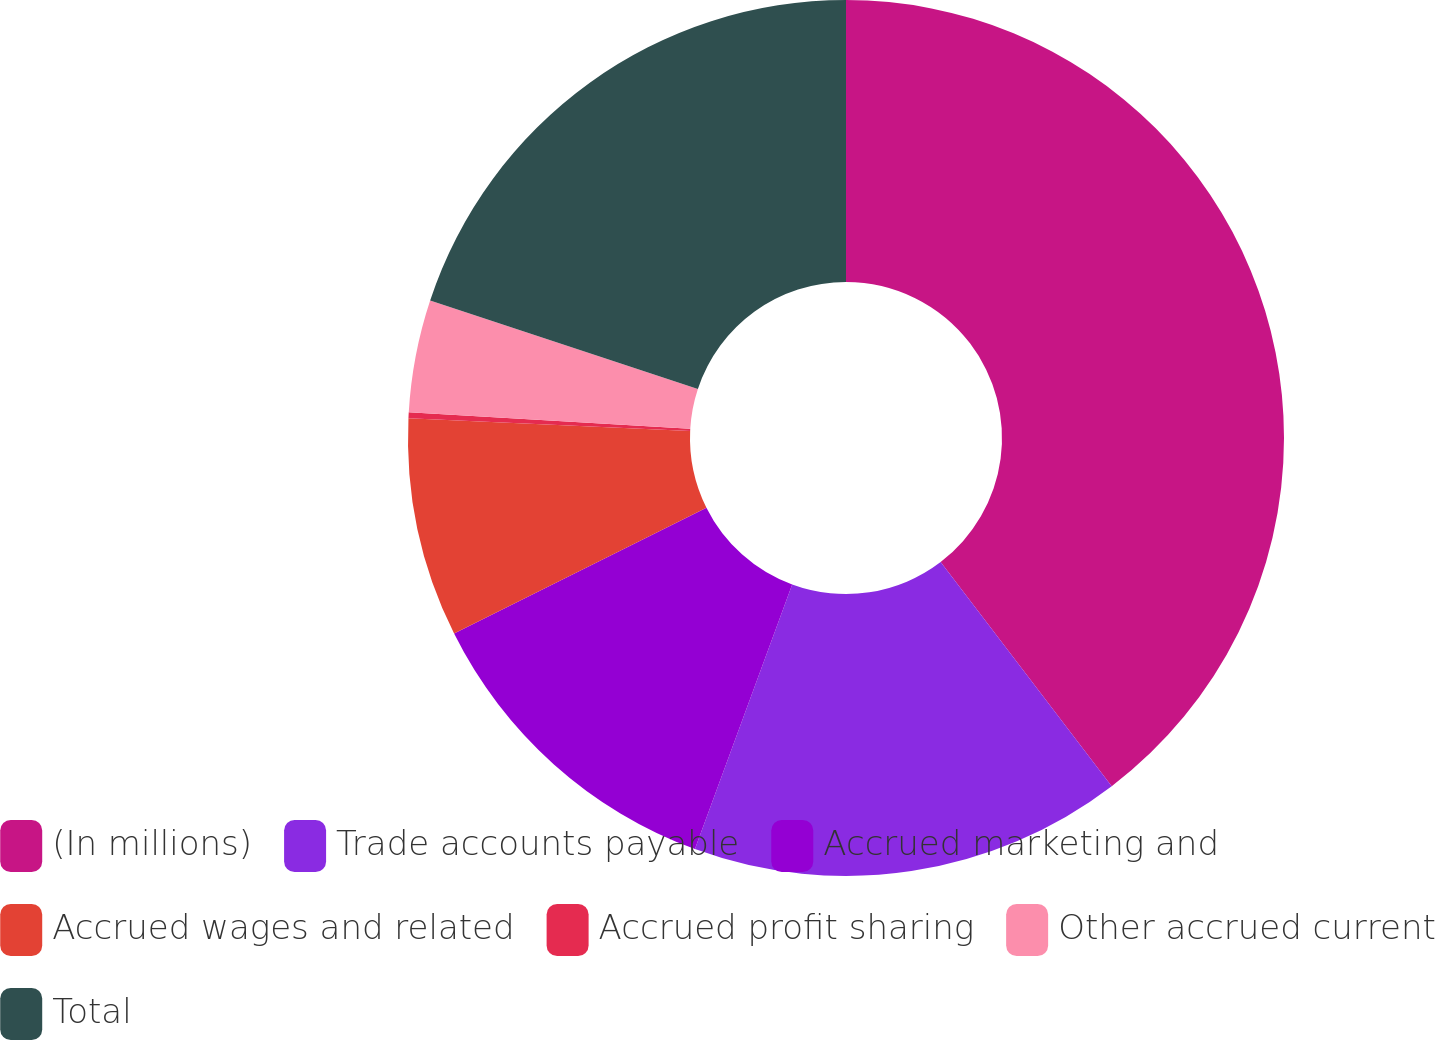Convert chart. <chart><loc_0><loc_0><loc_500><loc_500><pie_chart><fcel>(In millions)<fcel>Trade accounts payable<fcel>Accrued marketing and<fcel>Accrued wages and related<fcel>Accrued profit sharing<fcel>Other accrued current<fcel>Total<nl><fcel>39.63%<fcel>15.98%<fcel>12.03%<fcel>8.09%<fcel>0.21%<fcel>4.15%<fcel>19.92%<nl></chart> 